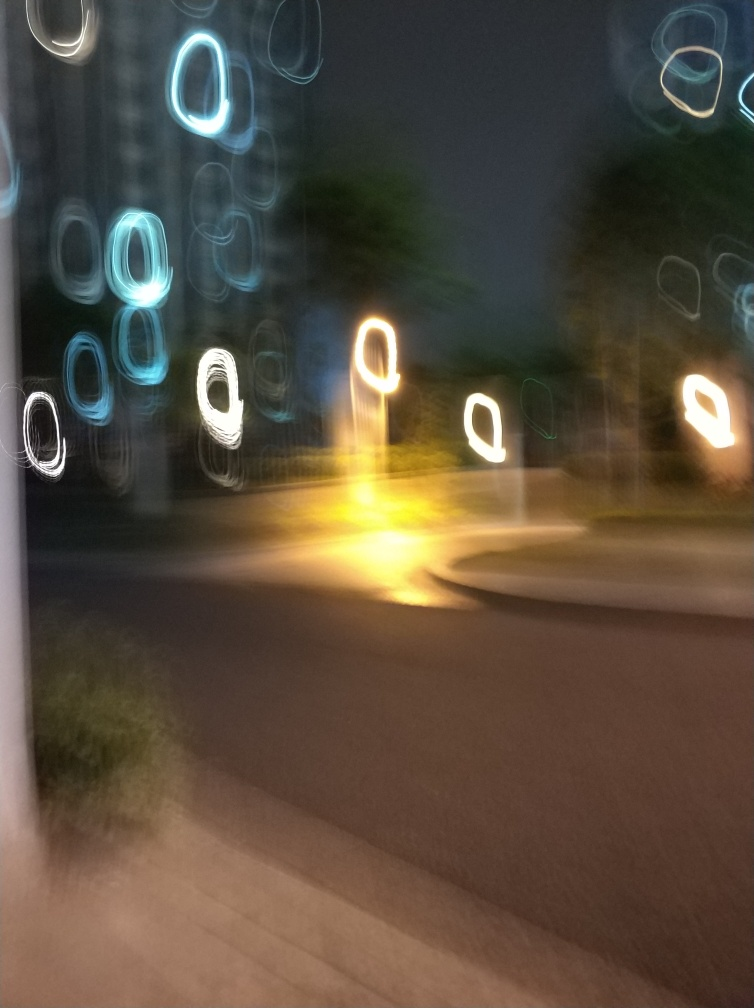How would you describe the clarity of this image? The clarity of the image is quite low, as it exhibits significant blur and light streaks, suggesting camera movement during the exposure or a low shutter speed in low-light conditions. Instead of clear and sharp details, we have abstract shapes and colors that give the photo an impressionistic feel. 